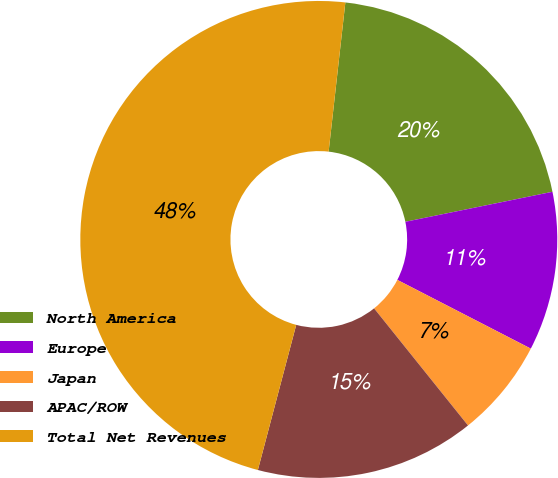Convert chart to OTSL. <chart><loc_0><loc_0><loc_500><loc_500><pie_chart><fcel>North America<fcel>Europe<fcel>Japan<fcel>APAC/ROW<fcel>Total Net Revenues<nl><fcel>20.02%<fcel>10.77%<fcel>6.67%<fcel>14.87%<fcel>47.66%<nl></chart> 